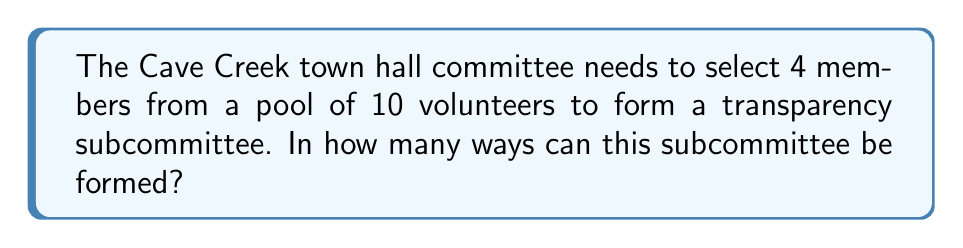Teach me how to tackle this problem. To solve this problem, we need to use the combination formula. We are selecting 4 people from a group of 10, where the order of selection doesn't matter (as it's a committee, not a ranked list).

The formula for combinations is:

$$C(n,r) = \frac{n!}{r!(n-r)!}$$

Where:
$n$ is the total number of items to choose from (in this case, 10 volunteers)
$r$ is the number of items being chosen (in this case, 4 committee members)

Let's plug in our values:

$$C(10,4) = \frac{10!}{4!(10-4)!} = \frac{10!}{4!6!}$$

Now, let's calculate this step-by-step:

1) $10! = 10 \times 9 \times 8 \times 7 \times 6!$
2) $4! = 4 \times 3 \times 2 \times 1 = 24$

So our equation becomes:

$$\frac{10 \times 9 \times 8 \times 7 \times 6!}{24 \times 6!}$$

The $6!$ cancels out in the numerator and denominator:

$$\frac{10 \times 9 \times 8 \times 7}{24}$$

Now let's multiply the numerator:

$$\frac{5040}{24}$$

Finally, divide:

$$210$$

Therefore, there are 210 possible ways to form the subcommittee.
Answer: 210 